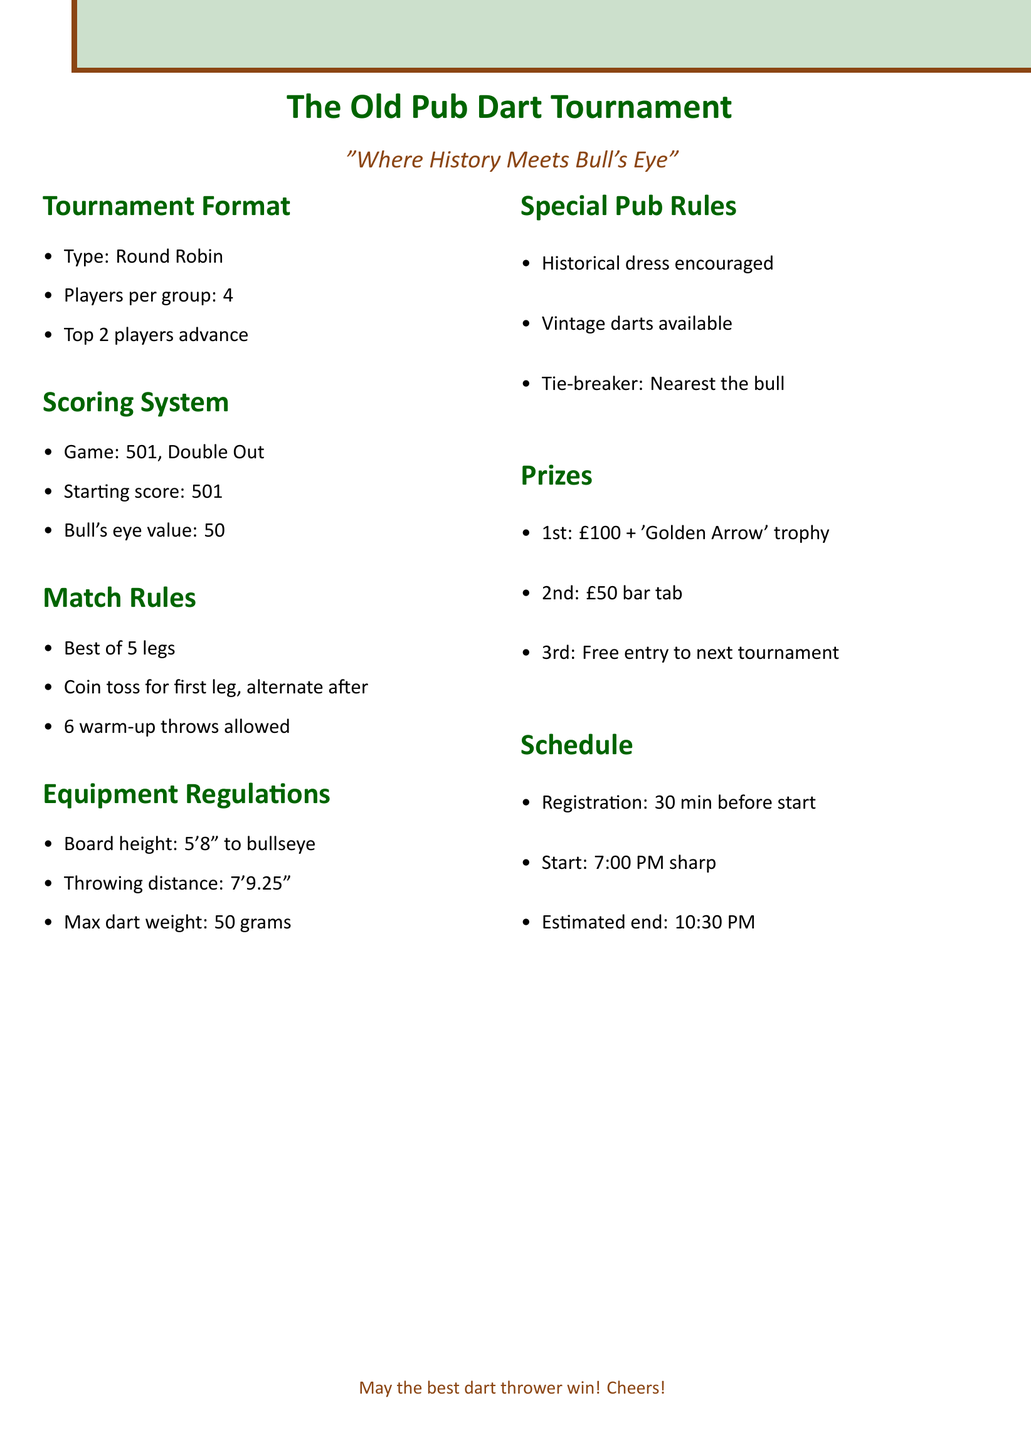What is the tournament format? The tournament format is specified in the document, identifying the type and structure of the event to be held.
Answer: Round Robin How many players are in each group? The number of players in each group is clearly stated in the tournament format section of the document.
Answer: 4 What is the starting score for the game type? The starting score is mentioned in the scoring system section of the document as part of the game rules.
Answer: 501 What is the prize for first place? The prizes for various placements are listed, indicating what the winner of the tournament will receive.
Answer: £100 cash + 'Golden Arrow' trophy When does the tournament start? The schedule section provides a clear time for the beginning of the tournament event, which is crucial for participants.
Answer: 7:00 PM sharp How many legs are played per match? The match rules indicate how many legs will be contested in each match, helping to clarify the structure of competition.
Answer: Best of 5 What is the equipment dart weight limit? The document specifies the maximum weight limit for darts allowed in the tournament regulations, which is important for participants.
Answer: 50 grams What happens in case of a tie? The special pub rules outline the procedure for resolving ties, essential for ensuring fair competition among players.
Answer: Nearest the bull, sudden death What is encouraged but not mandatory for participants? The document lists a special pub rule that is optional for participants to enhance the themed event experience.
Answer: Historical dress 